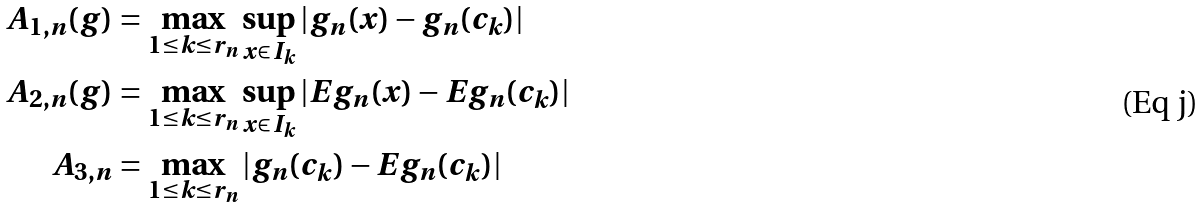<formula> <loc_0><loc_0><loc_500><loc_500>A _ { 1 , n } ( g ) & = \max _ { 1 \leq k \leq r _ { n } } \sup _ { x \in I _ { k } } | g _ { n } ( x ) - g _ { n } ( c _ { k } ) | \\ A _ { 2 , n } ( g ) & = \max _ { 1 \leq k \leq r _ { n } } \sup _ { x \in I _ { k } } | E g _ { n } ( x ) - E g _ { n } ( c _ { k } ) | \\ A _ { 3 , n } & = \max _ { 1 \leq k \leq r _ { n } } | g _ { n } ( c _ { k } ) - E g _ { n } ( c _ { k } ) |</formula> 